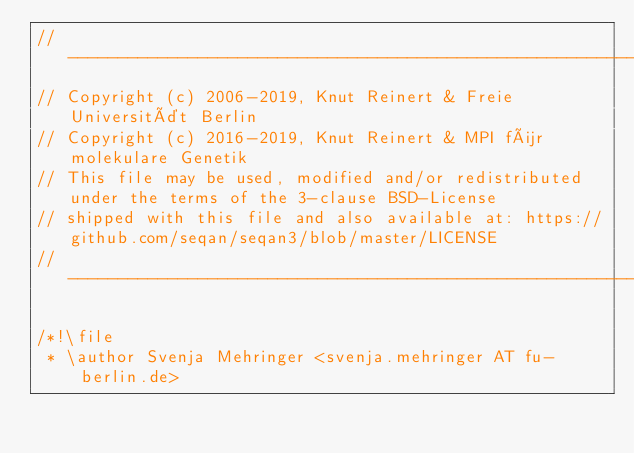<code> <loc_0><loc_0><loc_500><loc_500><_C++_>// -----------------------------------------------------------------------------------------------------
// Copyright (c) 2006-2019, Knut Reinert & Freie Universität Berlin
// Copyright (c) 2016-2019, Knut Reinert & MPI für molekulare Genetik
// This file may be used, modified and/or redistributed under the terms of the 3-clause BSD-License
// shipped with this file and also available at: https://github.com/seqan/seqan3/blob/master/LICENSE
// -----------------------------------------------------------------------------------------------------

/*!\file
 * \author Svenja Mehringer <svenja.mehringer AT fu-berlin.de></code> 